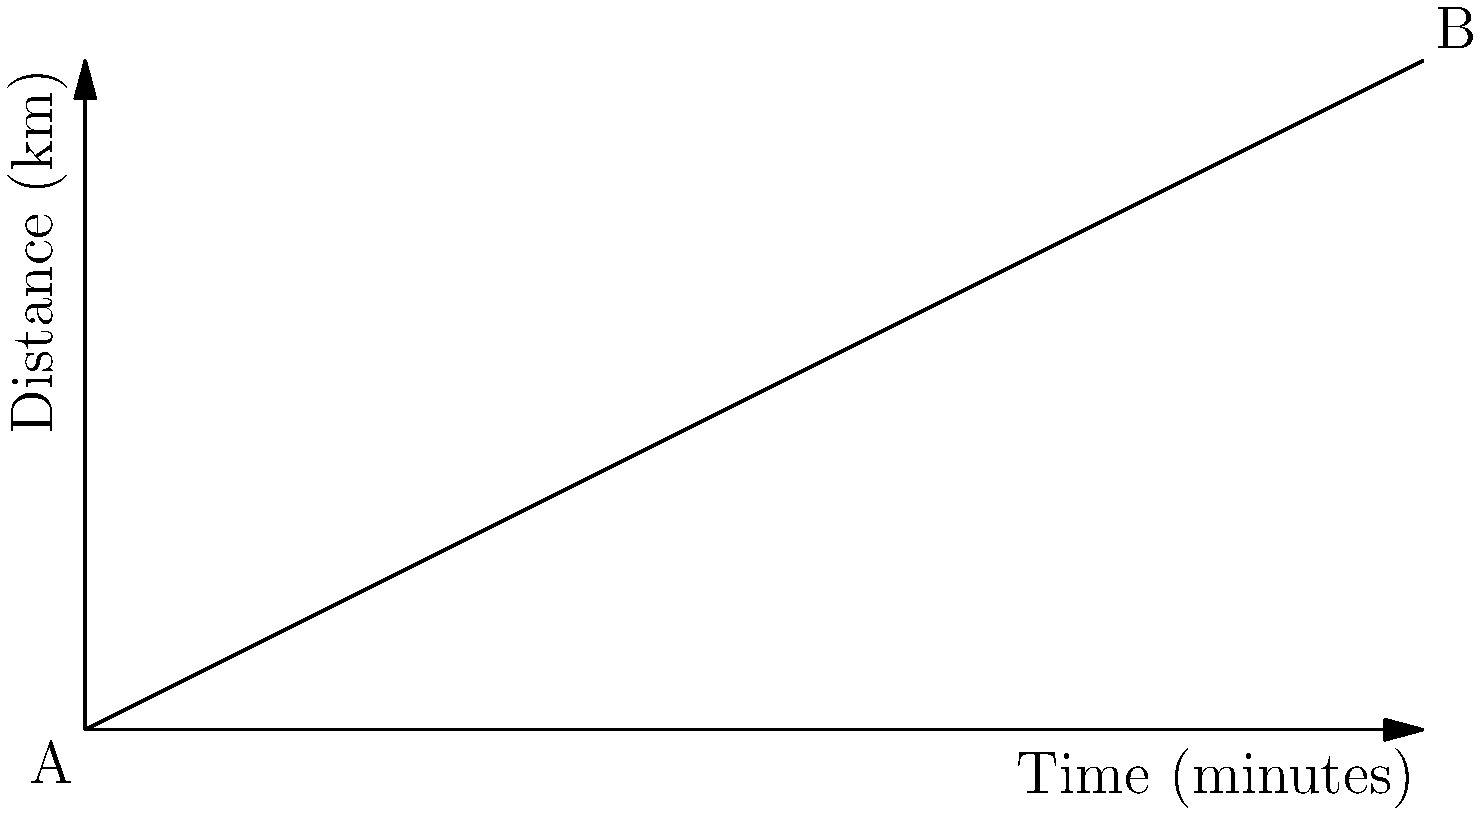During a less crowded time, you decide to take a train from Cleethorpes to Grimsby. The distance-time graph for your journey is shown above. What is the average speed of the train for this journey? To find the average speed, we need to determine the total distance traveled and the total time taken. Then we can use the formula:

Average Speed = Total Distance / Total Time

From the graph:
1. Start point A: (0 minutes, 0 km)
2. End point B: (60 minutes, 30 km)

Total distance:
$$ \text{Distance} = 30 \text{ km} - 0 \text{ km} = 30 \text{ km} $$

Total time:
$$ \text{Time} = 60 \text{ minutes} = 1 \text{ hour} $$

Now, let's calculate the average speed:

$$ \text{Average Speed} = \frac{\text{Total Distance}}{\text{Total Time}} = \frac{30 \text{ km}}{1 \text{ hour}} = 30 \text{ km/h} $$

Therefore, the average speed of the train for this journey is 30 km/h.
Answer: 30 km/h 